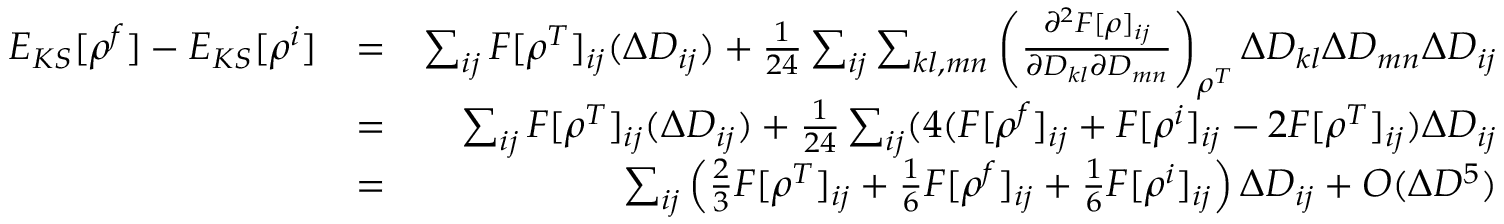Convert formula to latex. <formula><loc_0><loc_0><loc_500><loc_500>\begin{array} { r l r } { E _ { K S } [ \rho ^ { f } ] - E _ { K S } [ \rho ^ { i } ] } & { = } & { \sum _ { i j } F [ \rho ^ { T } ] _ { i j } ( \Delta D _ { i j } ) + \frac { 1 } { 2 4 } \sum _ { i j } \sum _ { k l , m n } \left ( \frac { \partial ^ { 2 } F [ \rho ] _ { i j } } { \partial D _ { k l } \partial D _ { m n } } \right ) _ { \rho ^ { T } } \Delta D _ { k l } \Delta D _ { m n } \Delta D _ { i j } } \\ & { = } & { \sum _ { i j } F [ \rho ^ { T } ] _ { i j } ( \Delta D _ { i j } ) + \frac { 1 } { 2 4 } \sum _ { i j } ( 4 ( F [ \rho ^ { f } ] _ { i j } + F [ \rho ^ { i } ] _ { i j } - 2 F [ \rho ^ { T } ] _ { i j } ) \Delta D _ { i j } } \\ & { = } & { \sum _ { i j } \left ( \frac { 2 } { 3 } F [ \rho ^ { T } ] _ { i j } + \frac { 1 } { 6 } F [ \rho ^ { f } ] _ { i j } + \frac { 1 } { 6 } F [ \rho ^ { i } ] _ { i j } \right ) \Delta D _ { i j } + O ( \Delta D ^ { 5 } ) } \end{array}</formula> 